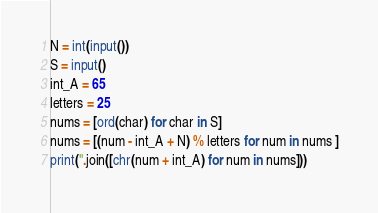<code> <loc_0><loc_0><loc_500><loc_500><_Python_>N = int(input())
S = input()
int_A = 65
letters = 25
nums = [ord(char) for char in S]
nums = [(num - int_A + N) % letters for num in nums ]
print(''.join([chr(num + int_A) for num in nums]))</code> 